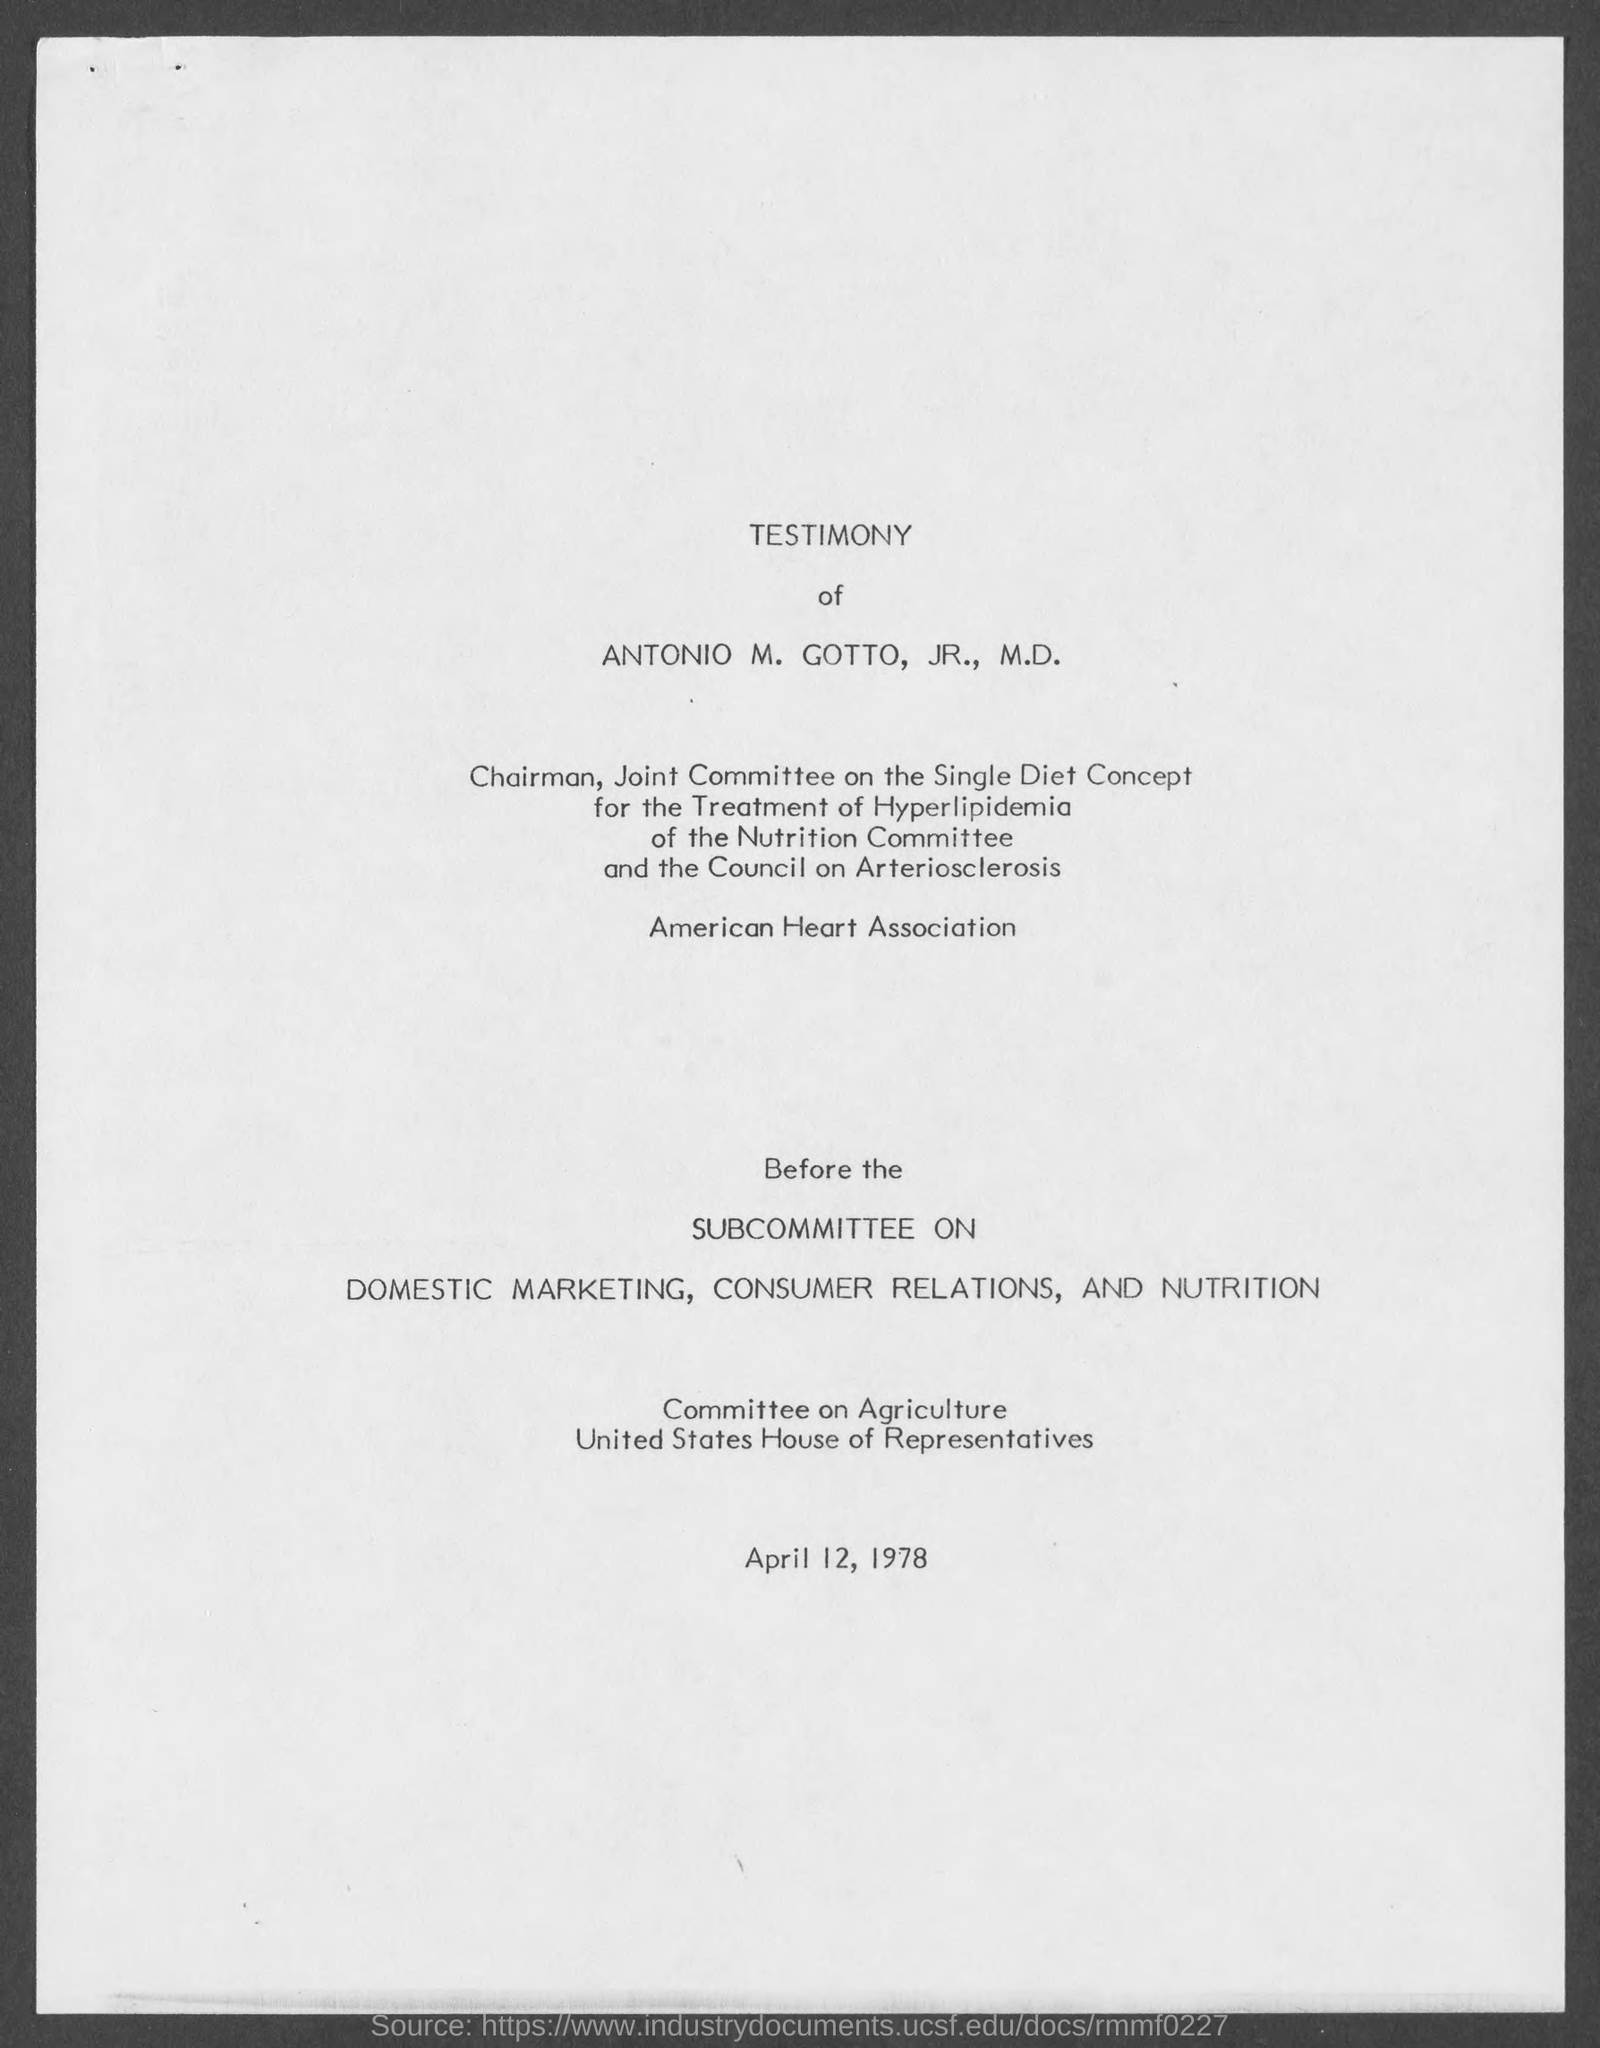Identify some key points in this picture. The date mentioned at the bottom of the page is April 12, 1978. The testimony being referred to is that of Antonio M. Gotto, Jr. 